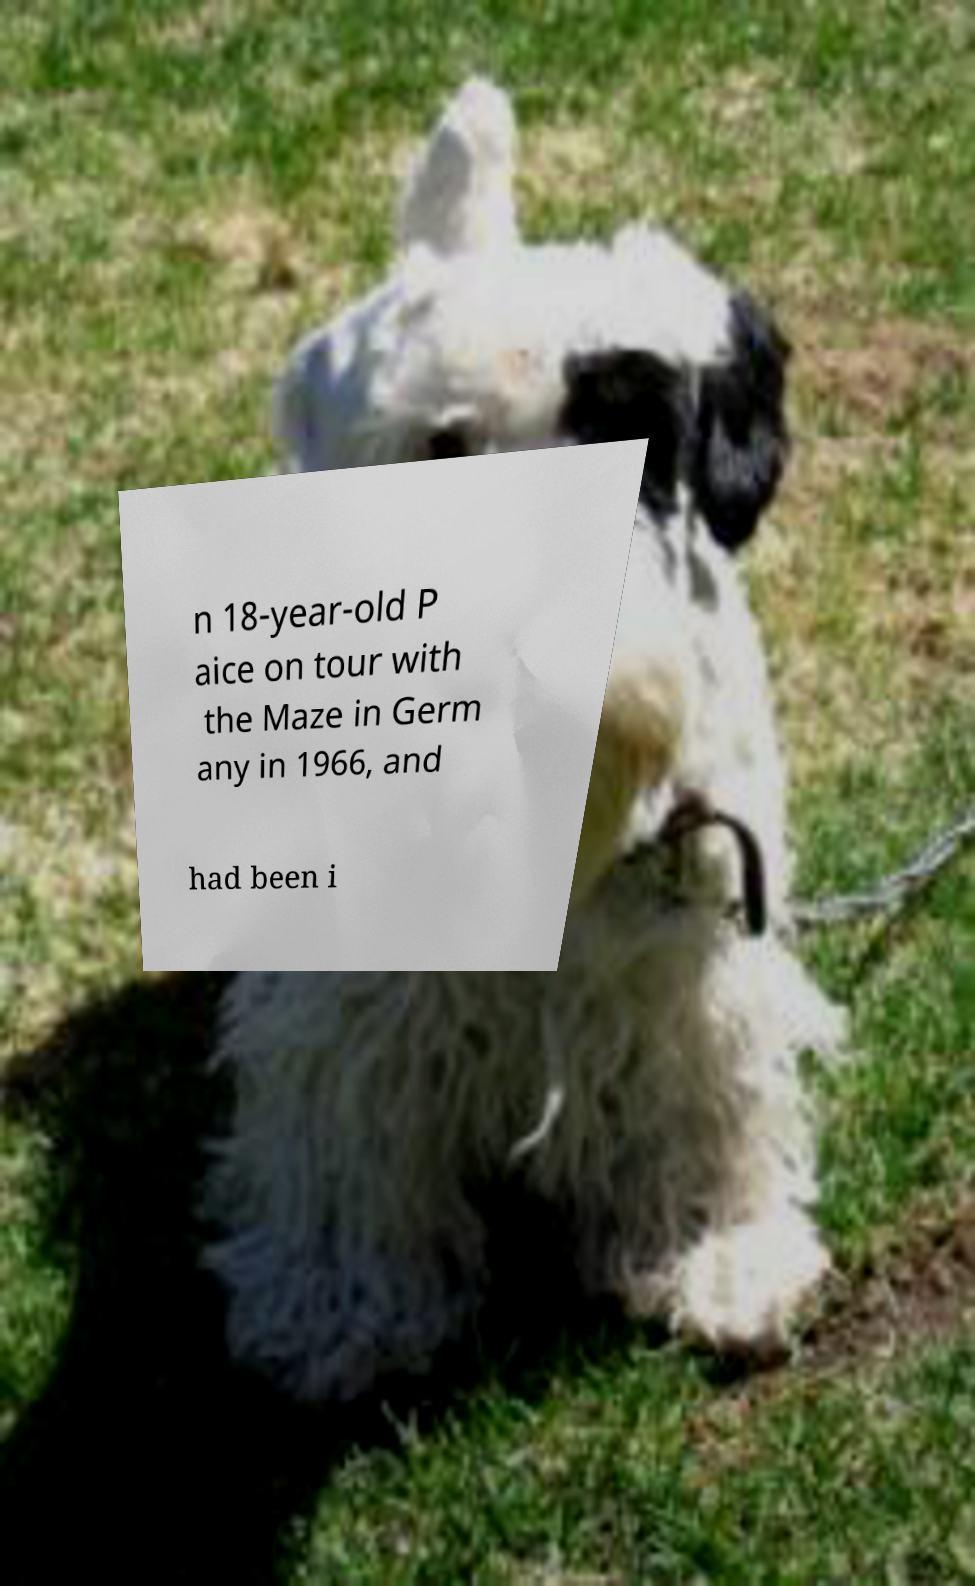Could you extract and type out the text from this image? n 18-year-old P aice on tour with the Maze in Germ any in 1966, and had been i 